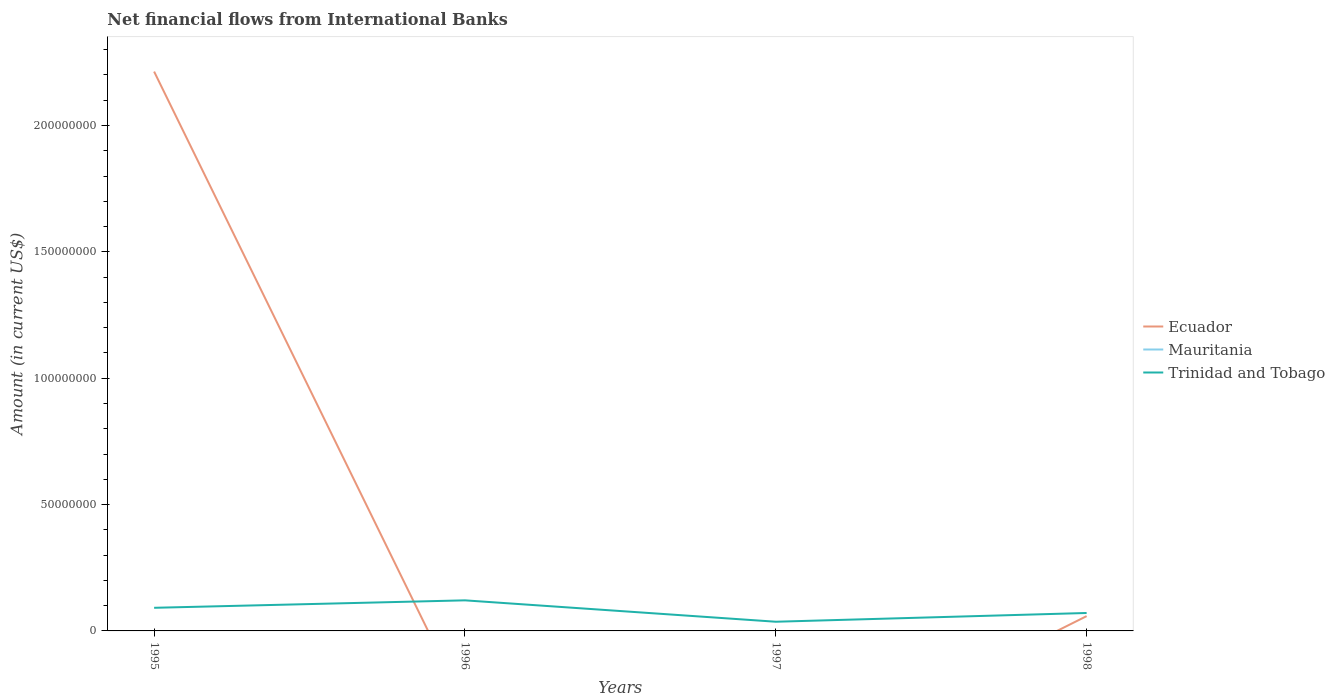How many different coloured lines are there?
Offer a terse response. 2. Is the number of lines equal to the number of legend labels?
Your answer should be very brief. No. What is the total net financial aid flows in Trinidad and Tobago in the graph?
Keep it short and to the point. 2.05e+06. What is the difference between the highest and the second highest net financial aid flows in Trinidad and Tobago?
Offer a very short reply. 8.46e+06. What is the difference between the highest and the lowest net financial aid flows in Ecuador?
Your answer should be very brief. 1. Is the net financial aid flows in Ecuador strictly greater than the net financial aid flows in Mauritania over the years?
Your response must be concise. No. Are the values on the major ticks of Y-axis written in scientific E-notation?
Give a very brief answer. No. Does the graph contain any zero values?
Keep it short and to the point. Yes. Where does the legend appear in the graph?
Your answer should be compact. Center right. What is the title of the graph?
Ensure brevity in your answer.  Net financial flows from International Banks. What is the label or title of the Y-axis?
Your answer should be compact. Amount (in current US$). What is the Amount (in current US$) in Ecuador in 1995?
Offer a terse response. 2.21e+08. What is the Amount (in current US$) in Trinidad and Tobago in 1995?
Keep it short and to the point. 9.15e+06. What is the Amount (in current US$) in Ecuador in 1996?
Offer a very short reply. 0. What is the Amount (in current US$) of Mauritania in 1996?
Ensure brevity in your answer.  0. What is the Amount (in current US$) of Trinidad and Tobago in 1996?
Ensure brevity in your answer.  1.21e+07. What is the Amount (in current US$) in Ecuador in 1997?
Offer a very short reply. 0. What is the Amount (in current US$) of Trinidad and Tobago in 1997?
Keep it short and to the point. 3.64e+06. What is the Amount (in current US$) in Ecuador in 1998?
Offer a very short reply. 5.85e+06. What is the Amount (in current US$) of Trinidad and Tobago in 1998?
Provide a succinct answer. 7.10e+06. Across all years, what is the maximum Amount (in current US$) of Ecuador?
Provide a short and direct response. 2.21e+08. Across all years, what is the maximum Amount (in current US$) of Trinidad and Tobago?
Your answer should be very brief. 1.21e+07. Across all years, what is the minimum Amount (in current US$) of Ecuador?
Offer a very short reply. 0. Across all years, what is the minimum Amount (in current US$) of Trinidad and Tobago?
Make the answer very short. 3.64e+06. What is the total Amount (in current US$) in Ecuador in the graph?
Make the answer very short. 2.27e+08. What is the total Amount (in current US$) in Mauritania in the graph?
Give a very brief answer. 0. What is the total Amount (in current US$) of Trinidad and Tobago in the graph?
Your response must be concise. 3.20e+07. What is the difference between the Amount (in current US$) in Trinidad and Tobago in 1995 and that in 1996?
Your answer should be very brief. -2.95e+06. What is the difference between the Amount (in current US$) of Trinidad and Tobago in 1995 and that in 1997?
Provide a short and direct response. 5.51e+06. What is the difference between the Amount (in current US$) of Ecuador in 1995 and that in 1998?
Your answer should be very brief. 2.15e+08. What is the difference between the Amount (in current US$) of Trinidad and Tobago in 1995 and that in 1998?
Your response must be concise. 2.05e+06. What is the difference between the Amount (in current US$) in Trinidad and Tobago in 1996 and that in 1997?
Your answer should be very brief. 8.46e+06. What is the difference between the Amount (in current US$) in Trinidad and Tobago in 1996 and that in 1998?
Offer a very short reply. 5.00e+06. What is the difference between the Amount (in current US$) in Trinidad and Tobago in 1997 and that in 1998?
Keep it short and to the point. -3.46e+06. What is the difference between the Amount (in current US$) of Ecuador in 1995 and the Amount (in current US$) of Trinidad and Tobago in 1996?
Make the answer very short. 2.09e+08. What is the difference between the Amount (in current US$) of Ecuador in 1995 and the Amount (in current US$) of Trinidad and Tobago in 1997?
Your answer should be compact. 2.18e+08. What is the difference between the Amount (in current US$) of Ecuador in 1995 and the Amount (in current US$) of Trinidad and Tobago in 1998?
Make the answer very short. 2.14e+08. What is the average Amount (in current US$) of Ecuador per year?
Give a very brief answer. 5.68e+07. What is the average Amount (in current US$) in Mauritania per year?
Offer a terse response. 0. What is the average Amount (in current US$) in Trinidad and Tobago per year?
Provide a short and direct response. 8.00e+06. In the year 1995, what is the difference between the Amount (in current US$) in Ecuador and Amount (in current US$) in Trinidad and Tobago?
Your response must be concise. 2.12e+08. In the year 1998, what is the difference between the Amount (in current US$) in Ecuador and Amount (in current US$) in Trinidad and Tobago?
Offer a very short reply. -1.24e+06. What is the ratio of the Amount (in current US$) in Trinidad and Tobago in 1995 to that in 1996?
Your answer should be compact. 0.76. What is the ratio of the Amount (in current US$) of Trinidad and Tobago in 1995 to that in 1997?
Provide a succinct answer. 2.52. What is the ratio of the Amount (in current US$) in Ecuador in 1995 to that in 1998?
Offer a very short reply. 37.81. What is the ratio of the Amount (in current US$) in Trinidad and Tobago in 1995 to that in 1998?
Offer a terse response. 1.29. What is the ratio of the Amount (in current US$) in Trinidad and Tobago in 1996 to that in 1997?
Your answer should be very brief. 3.33. What is the ratio of the Amount (in current US$) in Trinidad and Tobago in 1996 to that in 1998?
Your answer should be very brief. 1.7. What is the ratio of the Amount (in current US$) of Trinidad and Tobago in 1997 to that in 1998?
Your answer should be compact. 0.51. What is the difference between the highest and the second highest Amount (in current US$) in Trinidad and Tobago?
Give a very brief answer. 2.95e+06. What is the difference between the highest and the lowest Amount (in current US$) of Ecuador?
Your answer should be compact. 2.21e+08. What is the difference between the highest and the lowest Amount (in current US$) of Trinidad and Tobago?
Make the answer very short. 8.46e+06. 